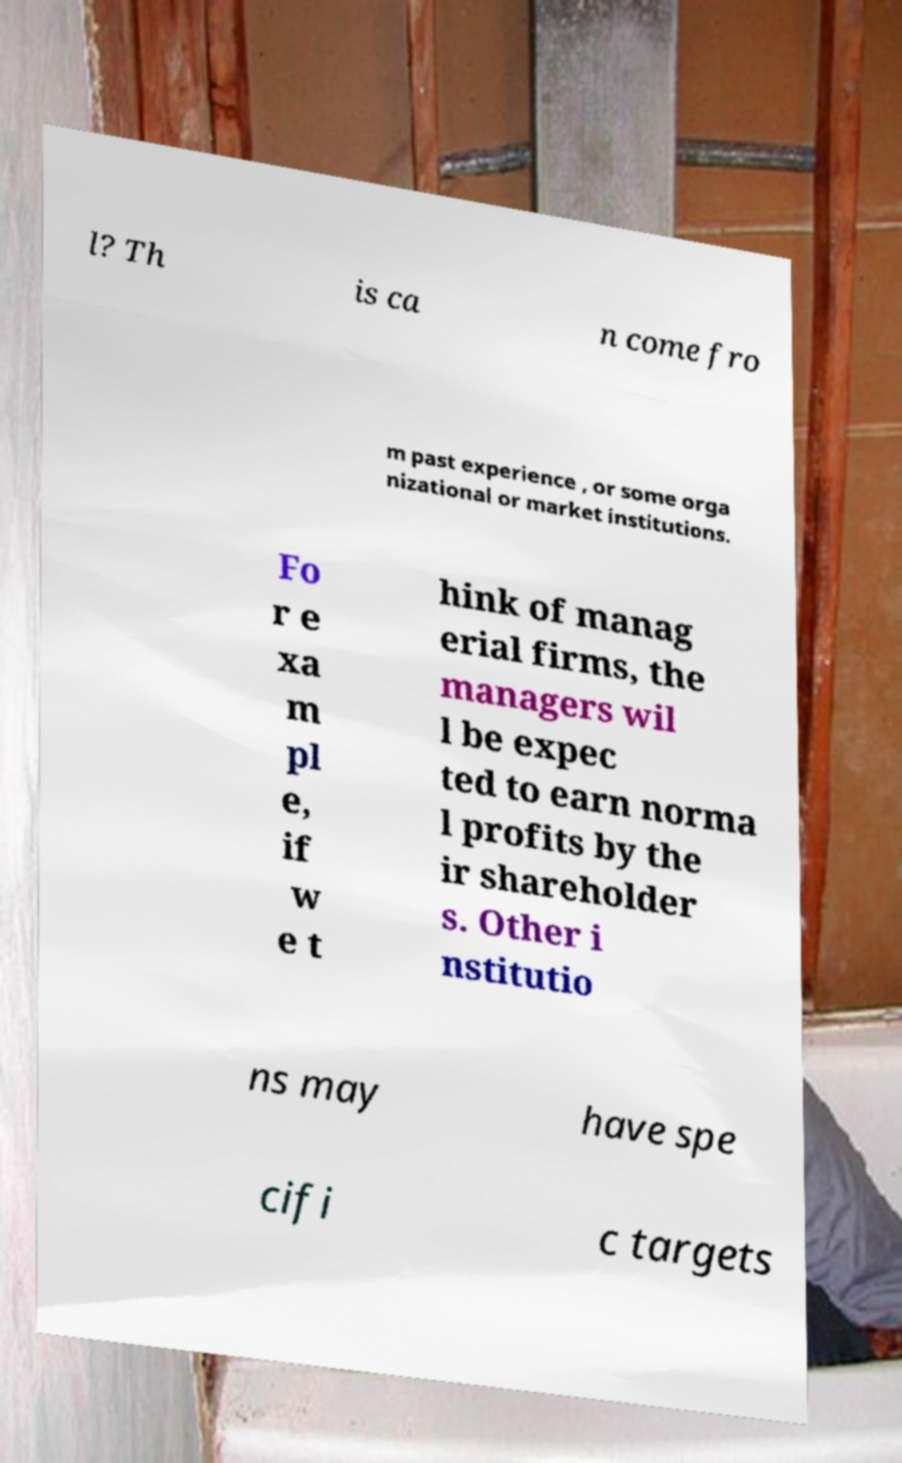Please identify and transcribe the text found in this image. l? Th is ca n come fro m past experience , or some orga nizational or market institutions. Fo r e xa m pl e, if w e t hink of manag erial firms, the managers wil l be expec ted to earn norma l profits by the ir shareholder s. Other i nstitutio ns may have spe cifi c targets 